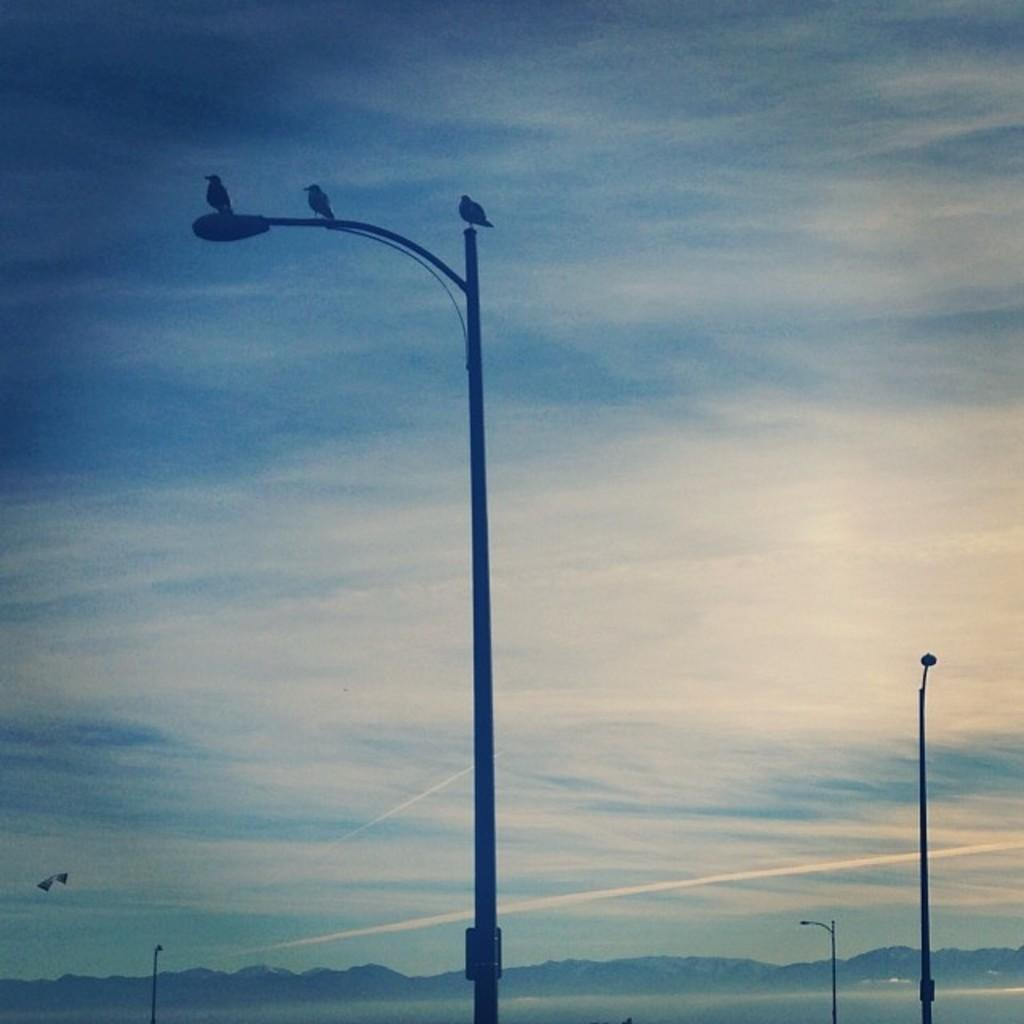What structure can be seen in the image? There is a light pole in the image. What is on top of the light pole? Birds are sitting on the light pole. What is the condition of the sky in the image? The sky is cloudy in the image. Can you read the note that the servant is holding in the image? There is no note or servant present in the image; it only features a light pole with birds sitting on it and a cloudy sky. 